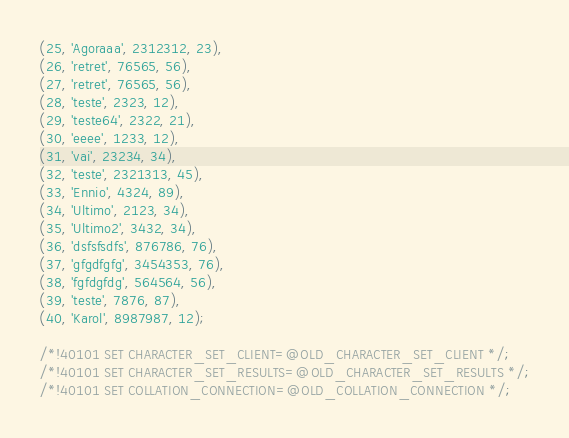Convert code to text. <code><loc_0><loc_0><loc_500><loc_500><_SQL_>(25, 'Agoraaa', 2312312, 23),
(26, 'retret', 76565, 56),
(27, 'retret', 76565, 56),
(28, 'teste', 2323, 12),
(29, 'teste64', 2322, 21),
(30, 'eeee', 1233, 12),
(31, 'vai', 23234, 34),
(32, 'teste', 2321313, 45),
(33, 'Ennio', 4324, 89),
(34, 'Ultimo', 2123, 34),
(35, 'Ultimo2', 3432, 34),
(36, 'dsfsfsdfs', 876786, 76),
(37, 'gfgdfgfg', 3454353, 76),
(38, 'fgfdgfdg', 564564, 56),
(39, 'teste', 7876, 87),
(40, 'Karol', 8987987, 12);

/*!40101 SET CHARACTER_SET_CLIENT=@OLD_CHARACTER_SET_CLIENT */;
/*!40101 SET CHARACTER_SET_RESULTS=@OLD_CHARACTER_SET_RESULTS */;
/*!40101 SET COLLATION_CONNECTION=@OLD_COLLATION_CONNECTION */;
</code> 